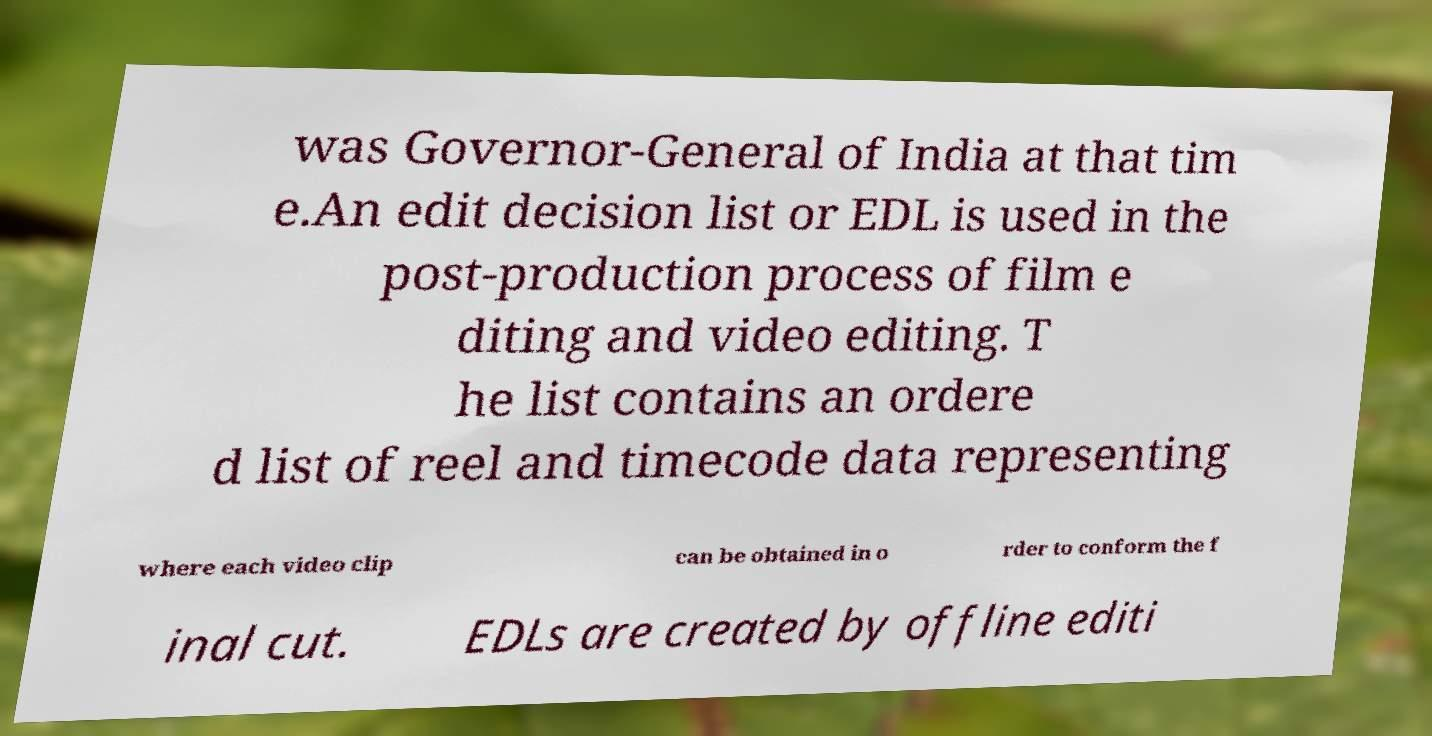There's text embedded in this image that I need extracted. Can you transcribe it verbatim? was Governor-General of India at that tim e.An edit decision list or EDL is used in the post-production process of film e diting and video editing. T he list contains an ordere d list of reel and timecode data representing where each video clip can be obtained in o rder to conform the f inal cut. EDLs are created by offline editi 